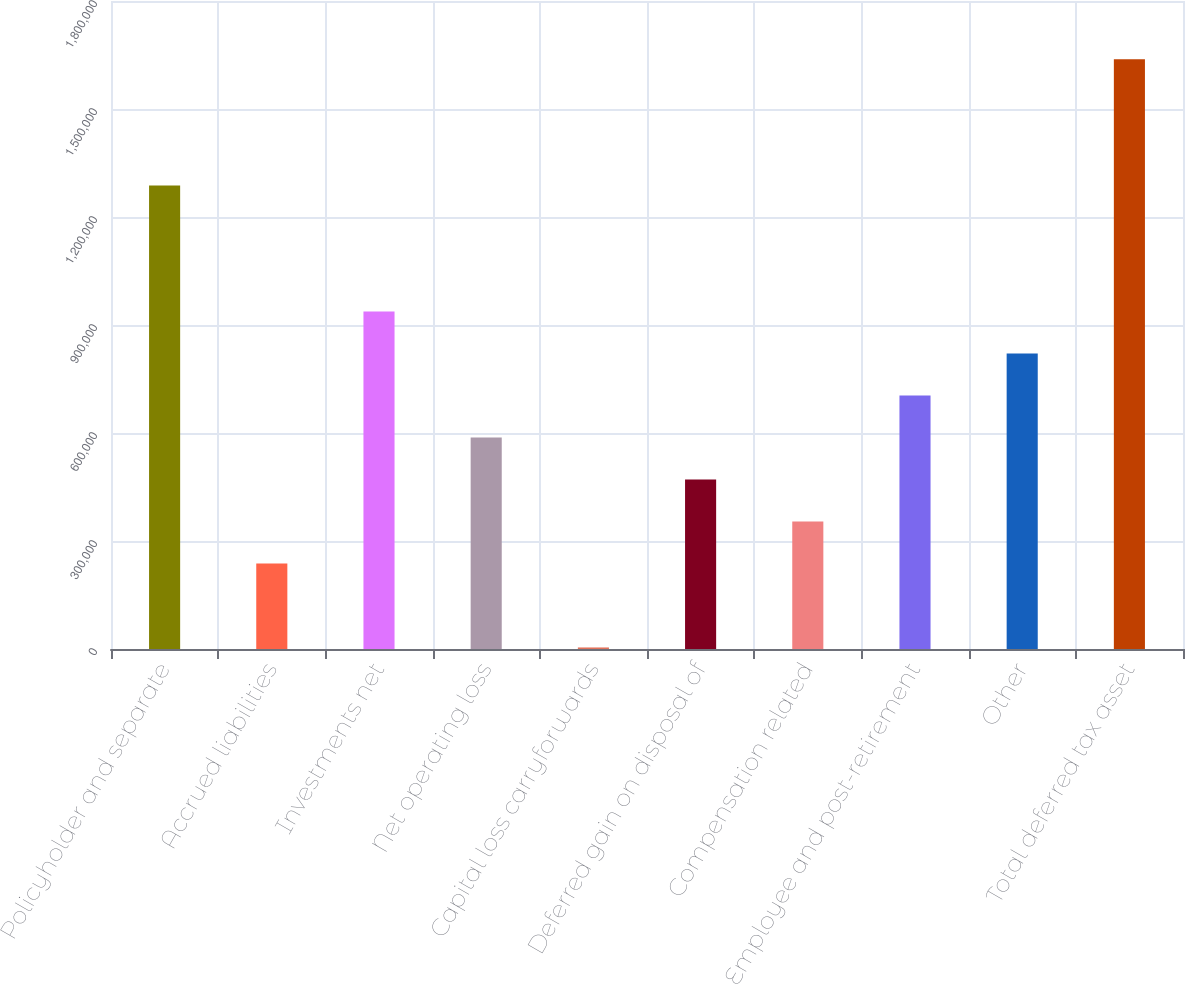Convert chart. <chart><loc_0><loc_0><loc_500><loc_500><bar_chart><fcel>Policyholder and separate<fcel>Accrued liabilities<fcel>Investments net<fcel>Net operating loss<fcel>Capital loss carryforwards<fcel>Deferred gain on disposal of<fcel>Compensation related<fcel>Employee and post-retirement<fcel>Other<fcel>Total deferred tax asset<nl><fcel>1.28782e+06<fcel>237664<fcel>937766<fcel>587715<fcel>4297<fcel>471031<fcel>354348<fcel>704399<fcel>821082<fcel>1.63787e+06<nl></chart> 